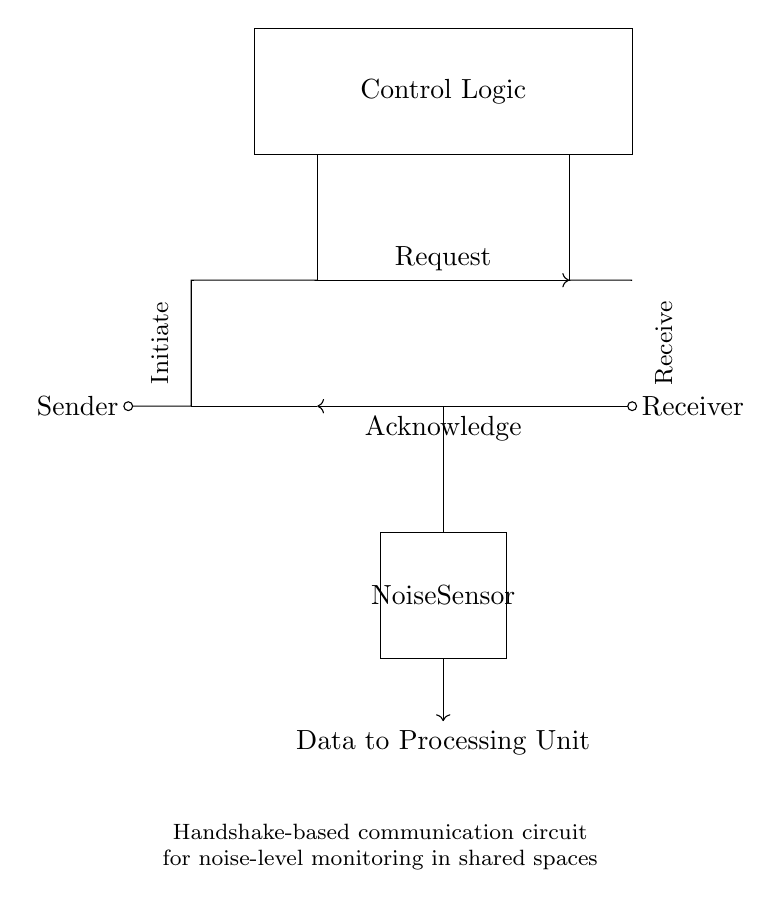What is the purpose of the noise sensor? The noise sensor is used to detect sound levels in the environment, play a critical role in monitoring noise, and contribute data to the processing unit for analysis.
Answer: Monitor noise levels What component initiates the communication? The circuit diagram shows the “Sender” as the component that initiates the communication by sending a Request signal to the Receiver.
Answer: Sender How many lines are used for communication in this circuit? The circuit has two communication lines: the Request line and the Acknowledge line, which facilitate the handshake communication mechanism.
Answer: Two What does the Control Logic block do? The Control Logic block processes the incoming signals from the Request and Acknowledge lines and manages the operation of the system, ensuring that proper communication is established between the Sender and Receiver.
Answer: Manage communication What type of circuit is this? The circuit represents a handshake-based communication system designed specifically for monitoring noise levels in shared public spaces, emphasizing asynchronous communication.
Answer: Handshake-based What connects the noise sensor to the processing unit? A designated line labeled “Data to Processing Unit” connects the noise sensor, signifying that it transmits the detected noise data for further processing.
Answer: Data line What is the direction of the Request signal? The Request signal flows from the Sender towards the Receiver, as indicated by the arrow direction on the Request line in the circuit diagram.
Answer: From Sender to Receiver 